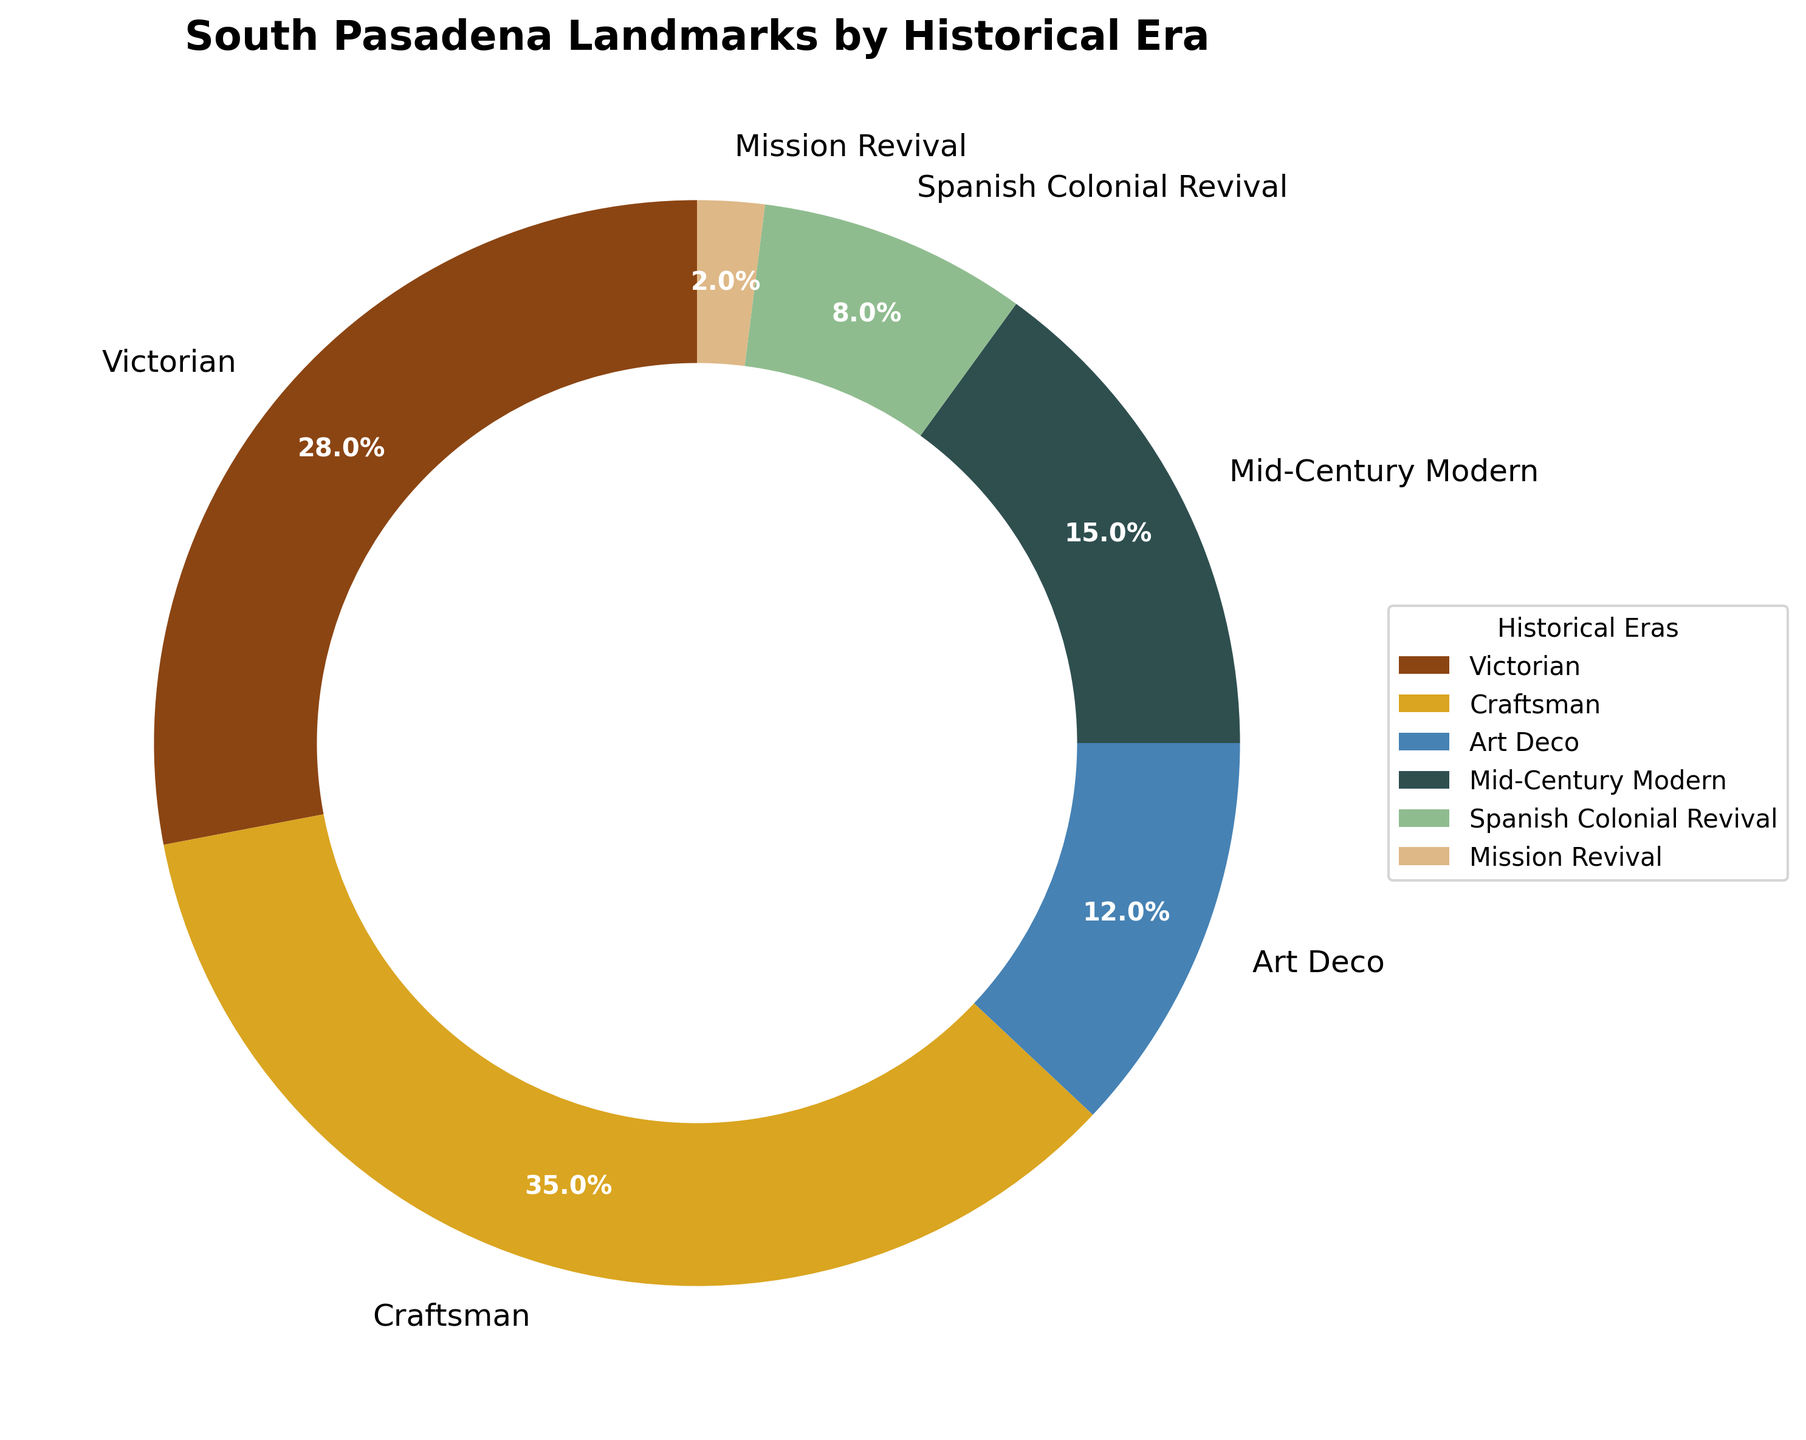What's the largest proportion of landmarks by historical era? To find the largest proportion, visually inspect the segment of the pie chart with the largest area. It corresponds to the 'Craftsman' era. The proportion is labeled as part of the pie chart.
Answer: 35% Which two historical eras have the smallest proportions of landmarks combined? Locate the two smallest segments by area in the pie chart. These segments are for the 'Mission Revival' and 'Spanish Colonial Revival' eras. The proportions are 2% and 8%, respectively.
Answer: Mission Revival and Spanish Colonial Revival What is the total proportion of landmarks accounted for by Victorian and Craftsman eras? To find the total, add the proportions of the Victorian (28%) and Craftsman (35%) eras.
Answer: 63% Which historical era has fewer landmarks, Art Deco or Mid-Century Modern? Compare the areas of the segments for Art Deco and Mid-Century Modern. The proportion for Art Deco is 12%, whereas it is 15% for Mid-Century Modern.
Answer: Art Deco How much larger is the proportion of Craftsman landmarks compared to Victorian landmarks? Subtract the proportion of Victorian (28%) landmarks from the proportion of Craftsman (35%) landmarks. 35% - 28% = 7%.
Answer: 7% What color represents the Mid-Century Modern era in the pie chart? Identify the color corresponding to the segment labeled 'Mid-Century Modern'. The visual attribute linked to Mid-Century Modern is a dark gray color.
Answer: Dark gray How much more significant is the proportion of Craftsman landmarks compared to Mission Revival landmarks? Subtract the proportion of Mission Revival (2%) landmarks from the proportion of Craftsman (35%) landmarks. 35% - 2% = 33%.
Answer: 33% What percentage of landmarks belong to either Art Deco or Spanish Colonial Revival eras? Add the proportions of the Art Deco (12%) and Spanish Colonial Revival (8%) eras. 12% + 8% = 20%.
Answer: 20% Among the listed historical eras, which one has the second smallest proportion? Inspect the areas of the segments, the second smallest proportion is for the Spanish Colonial Revival era at 8%.
Answer: Spanish Colonial Revival Is the proportion of Victorian landmarks greater than the combined proportion of Mission Revival and Spanish Colonial Revival landmarks? Compare the proportion of Victorian (28%) landmarks to the sum of Mission Revival (2%) and Spanish Colonial Revival (8%) landmarks. The sum is 2% + 8% = 10%, which is less than 28%.
Answer: Yes 